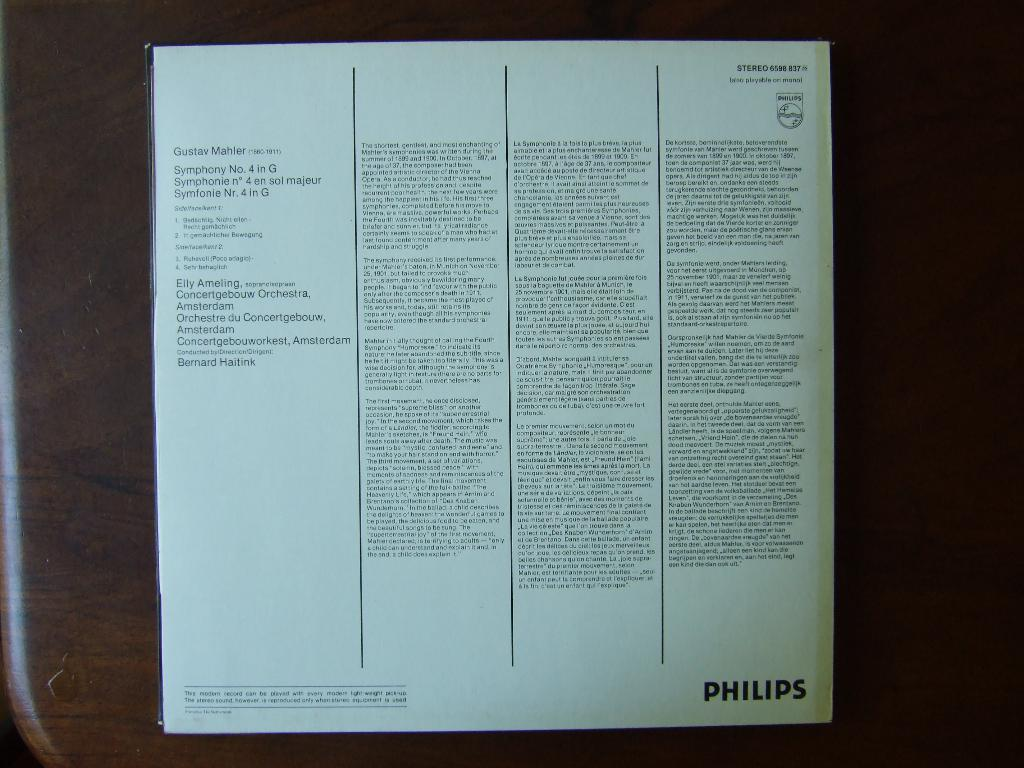What type of material is visible in the image? There is a white color magazine paper in the image. On what surface is the magazine paper placed? The magazine paper is placed on a wooden table top. What type of hook is used to hold the magazine paper in the image? There is no hook visible in the image; the magazine paper is simply placed on the wooden table top. What type of drug can be seen in the image? There is no drug present in the image; it is a white color magazine paper placed on a wooden table top. 